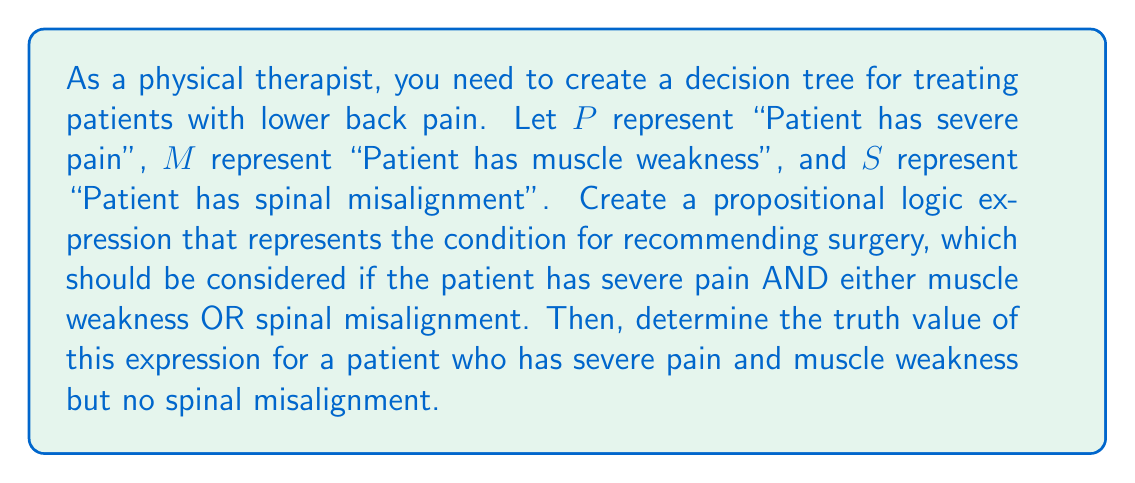Teach me how to tackle this problem. To solve this problem, we'll follow these steps:

1) First, let's create the propositional logic expression for recommending surgery:

   The condition is: severe pain AND (muscle weakness OR spinal misalignment)

   In propositional logic, this can be written as:

   $$ P \land (M \lor S) $$

   Where $\land$ represents AND, and $\lor$ represents OR.

2) Now, let's evaluate this expression for the given patient:
   - The patient has severe pain, so $P$ is true (T)
   - The patient has muscle weakness, so $M$ is true (T)
   - The patient does not have spinal misalignment, so $S$ is false (F)

3) Let's substitute these values into our expression:

   $$ T \land (T \lor F) $$

4) Evaluate the OR operation inside the parentheses first:
   $T \lor F = T$

   So our expression becomes:

   $$ T \land T $$

5) Finally, evaluate the AND operation:
   $T \land T = T$

Therefore, the entire expression evaluates to True.
Answer: The propositional logic expression is $P \land (M \lor S)$, and its truth value for the given patient is True. 